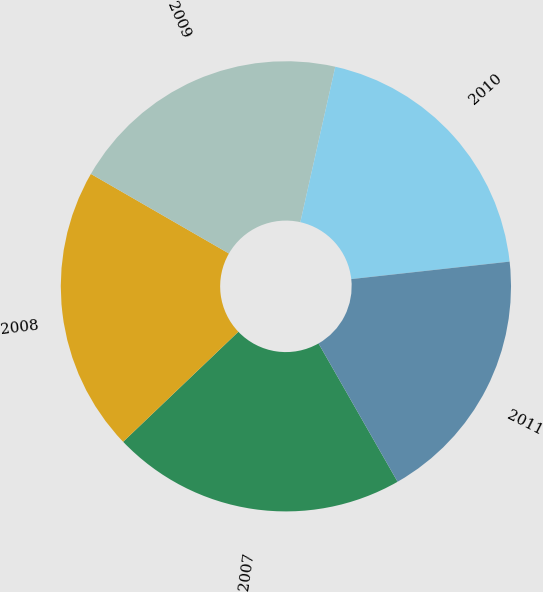Convert chart to OTSL. <chart><loc_0><loc_0><loc_500><loc_500><pie_chart><fcel>2007<fcel>2008<fcel>2009<fcel>2010<fcel>2011<nl><fcel>21.13%<fcel>20.46%<fcel>20.2%<fcel>19.73%<fcel>18.49%<nl></chart> 